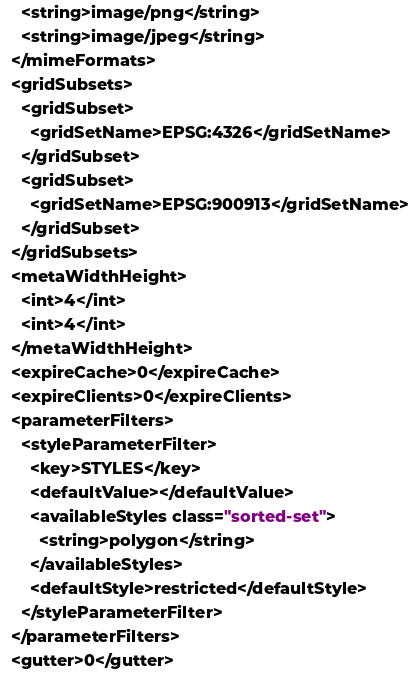Convert code to text. <code><loc_0><loc_0><loc_500><loc_500><_XML_>    <string>image/png</string>
    <string>image/jpeg</string>
  </mimeFormats>
  <gridSubsets>
    <gridSubset>
      <gridSetName>EPSG:4326</gridSetName>
    </gridSubset>
    <gridSubset>
      <gridSetName>EPSG:900913</gridSetName>
    </gridSubset>
  </gridSubsets>
  <metaWidthHeight>
    <int>4</int>
    <int>4</int>
  </metaWidthHeight>
  <expireCache>0</expireCache>
  <expireClients>0</expireClients>
  <parameterFilters>
    <styleParameterFilter>
      <key>STYLES</key>
      <defaultValue></defaultValue>
      <availableStyles class="sorted-set">
        <string>polygon</string>
      </availableStyles>
      <defaultStyle>restricted</defaultStyle>
    </styleParameterFilter>
  </parameterFilters>
  <gutter>0</gutter></code> 